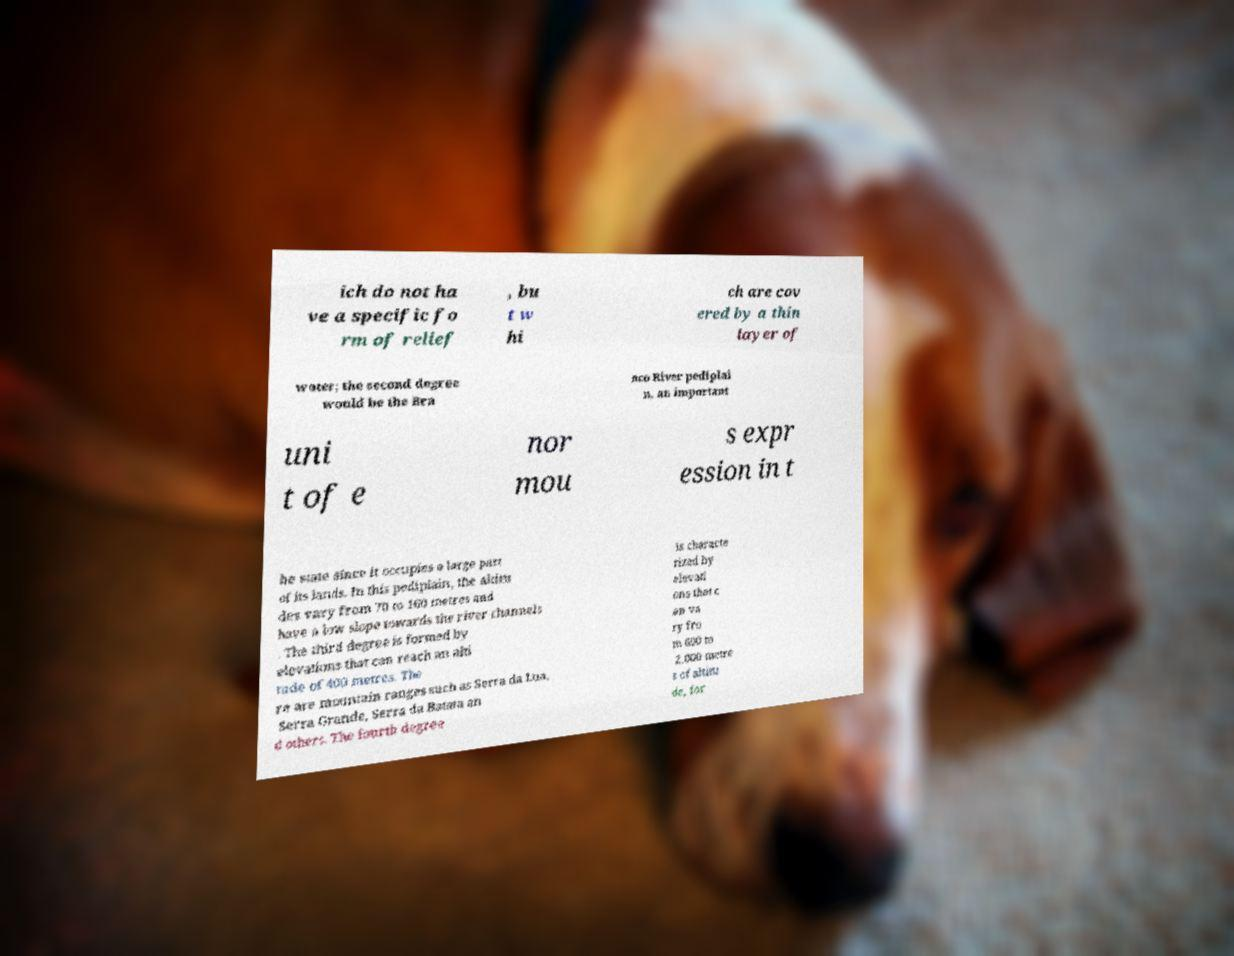Could you extract and type out the text from this image? ich do not ha ve a specific fo rm of relief , bu t w hi ch are cov ered by a thin layer of water; the second degree would be the Bra nco River pediplai n, an important uni t of e nor mou s expr ession in t he state since it occupies a large part of its lands. In this pediplain, the altitu des vary from 70 to 160 metres and have a low slope towards the river channels . The third degree is formed by elevations that can reach an alti tude of 400 metres. The re are mountain ranges such as Serra da Lua, Serra Grande, Serra da Batata an d others. The fourth degree is characte rized by elevati ons that c an va ry fro m 600 to 2,000 metre s of altitu de, for 